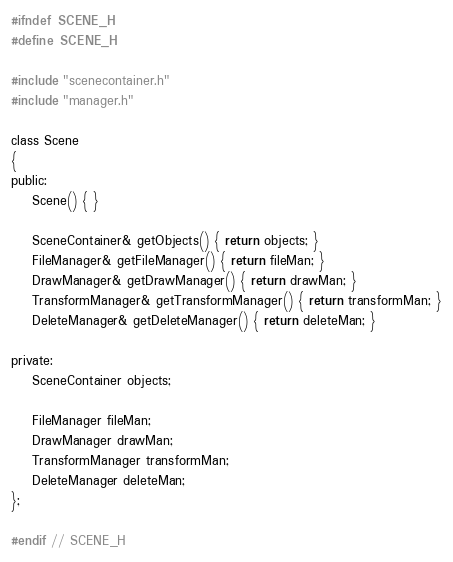Convert code to text. <code><loc_0><loc_0><loc_500><loc_500><_C_>#ifndef SCENE_H
#define SCENE_H

#include "scenecontainer.h"
#include "manager.h"

class Scene
{
public:
    Scene() { }

    SceneContainer& getObjects() { return objects; }
    FileManager& getFileManager() { return fileMan; }
    DrawManager& getDrawManager() { return drawMan; }
    TransformManager& getTransformManager() { return transformMan; }
    DeleteManager& getDeleteManager() { return deleteMan; }

private:
    SceneContainer objects;

    FileManager fileMan;
    DrawManager drawMan;
    TransformManager transformMan;
    DeleteManager deleteMan;
};

#endif // SCENE_H
</code> 